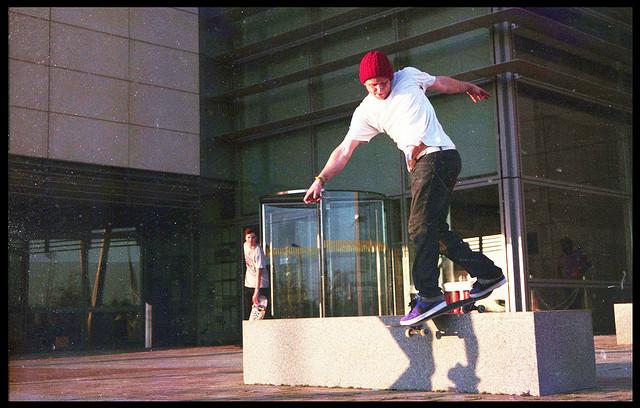Is there a revolving door in the background?
Give a very brief answer. Yes. What is the man riding his skateboard on?
Give a very brief answer. Cement block. Is the skateboard on the ground?
Answer briefly. No. 